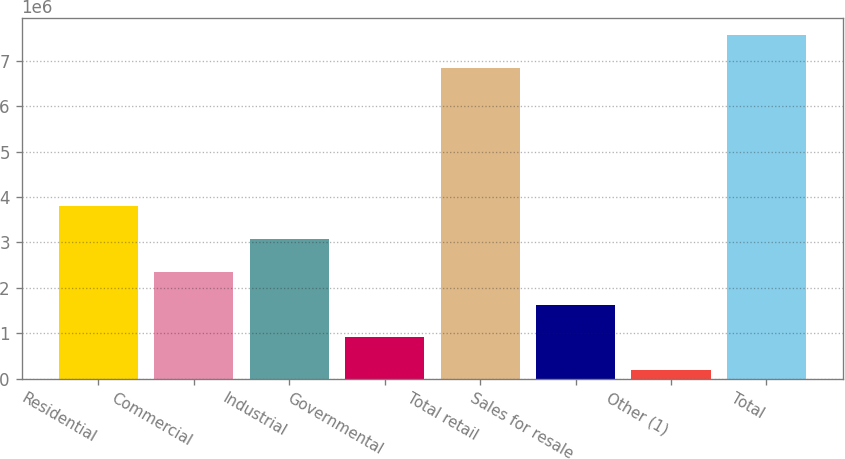<chart> <loc_0><loc_0><loc_500><loc_500><bar_chart><fcel>Residential<fcel>Commercial<fcel>Industrial<fcel>Governmental<fcel>Total retail<fcel>Sales for resale<fcel>Other (1)<fcel>Total<nl><fcel>3.79053e+06<fcel>2.34787e+06<fcel>3.0692e+06<fcel>905217<fcel>6.84164e+06<fcel>1.62655e+06<fcel>183888<fcel>7.56297e+06<nl></chart> 